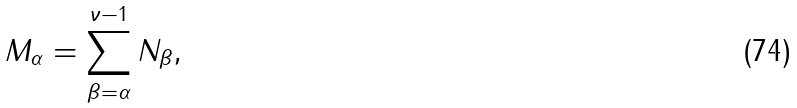Convert formula to latex. <formula><loc_0><loc_0><loc_500><loc_500>M _ { \alpha } = \sum _ { \beta = \alpha } ^ { \nu - 1 } N _ { \beta } ,</formula> 